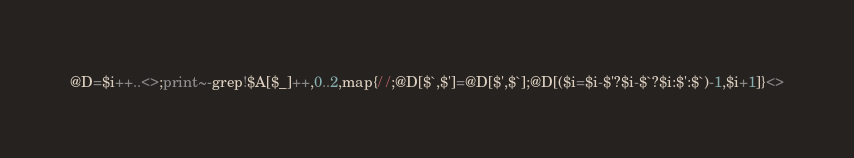Convert code to text. <code><loc_0><loc_0><loc_500><loc_500><_Perl_>@D=$i++..<>;print~-grep!$A[$_]++,0..2,map{/ /;@D[$`,$']=@D[$',$`];@D[($i=$i-$'?$i-$`?$i:$':$`)-1,$i+1]}<></code> 